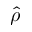Convert formula to latex. <formula><loc_0><loc_0><loc_500><loc_500>\widehat { \rho }</formula> 